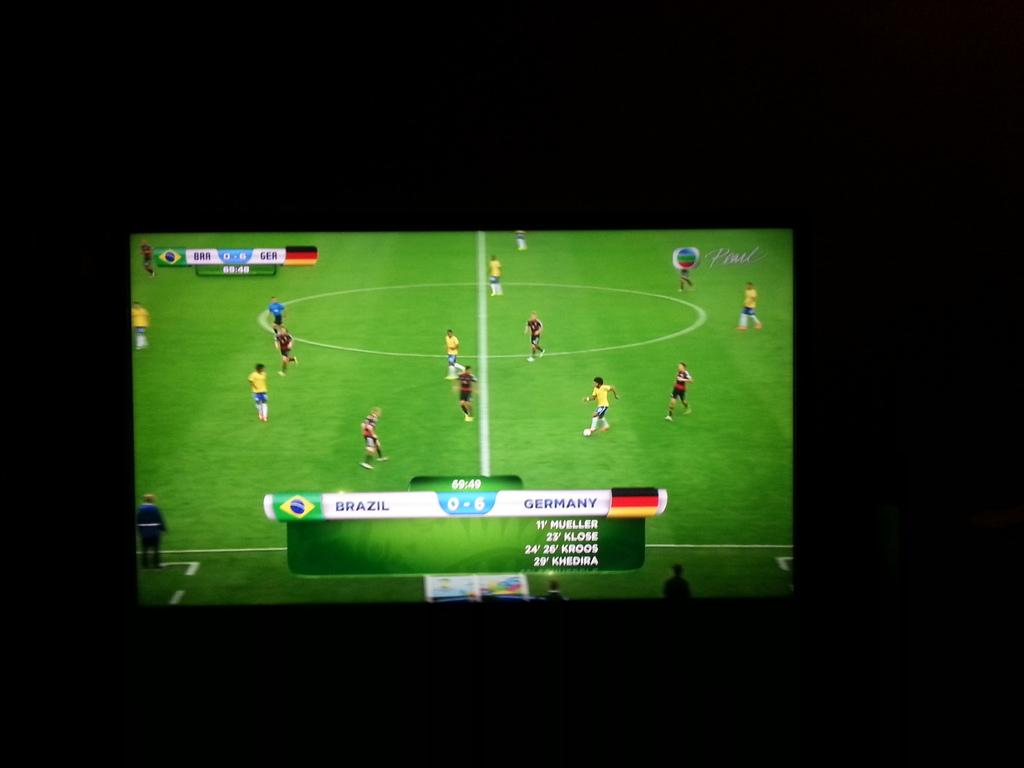<image>
Offer a succinct explanation of the picture presented. A soccer match between Brazil and Germany is on a television. 